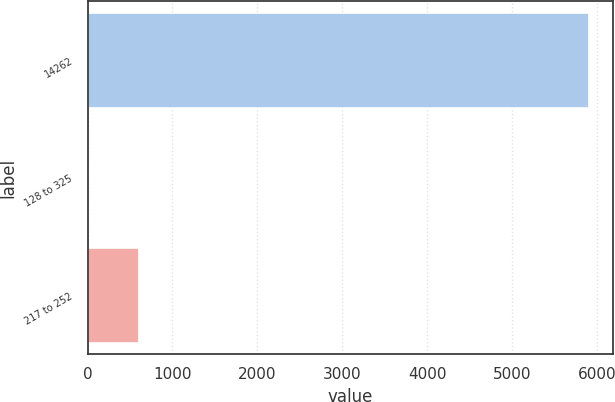Convert chart. <chart><loc_0><loc_0><loc_500><loc_500><bar_chart><fcel>14262<fcel>128 to 325<fcel>217 to 252<nl><fcel>5897.8<fcel>2.08<fcel>591.65<nl></chart> 